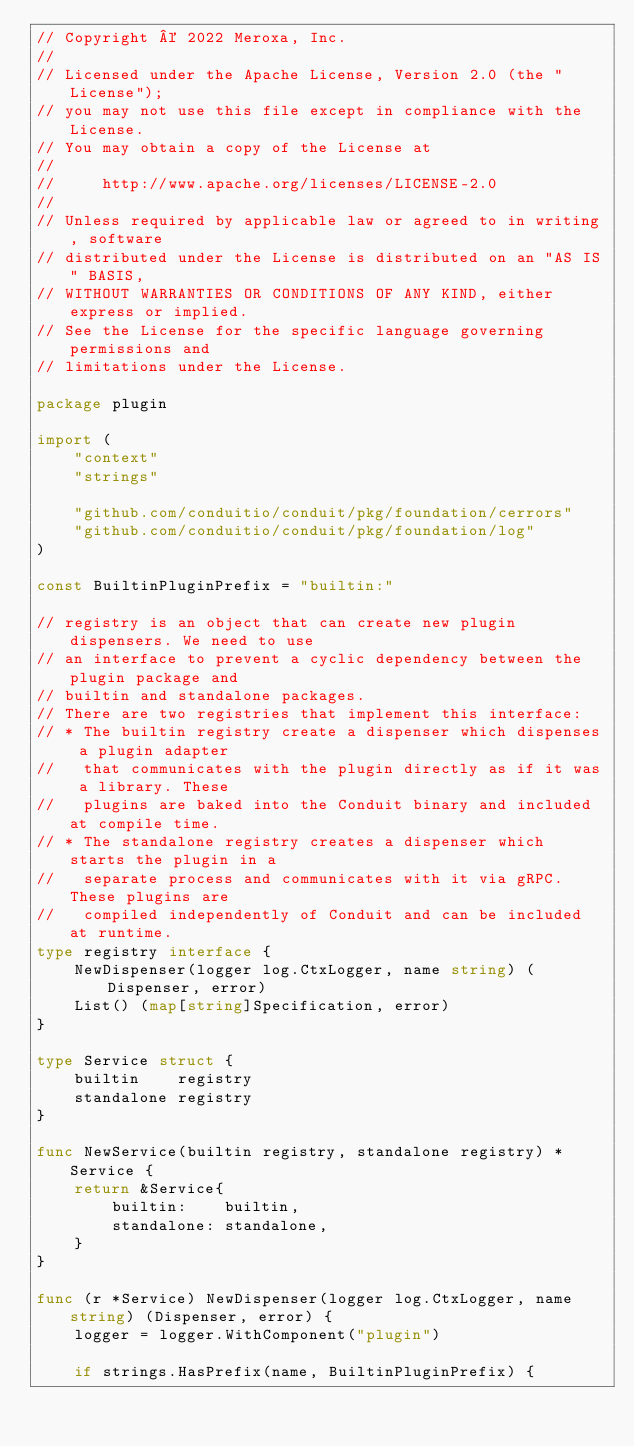<code> <loc_0><loc_0><loc_500><loc_500><_Go_>// Copyright © 2022 Meroxa, Inc.
//
// Licensed under the Apache License, Version 2.0 (the "License");
// you may not use this file except in compliance with the License.
// You may obtain a copy of the License at
//
//     http://www.apache.org/licenses/LICENSE-2.0
//
// Unless required by applicable law or agreed to in writing, software
// distributed under the License is distributed on an "AS IS" BASIS,
// WITHOUT WARRANTIES OR CONDITIONS OF ANY KIND, either express or implied.
// See the License for the specific language governing permissions and
// limitations under the License.

package plugin

import (
	"context"
	"strings"

	"github.com/conduitio/conduit/pkg/foundation/cerrors"
	"github.com/conduitio/conduit/pkg/foundation/log"
)

const BuiltinPluginPrefix = "builtin:"

// registry is an object that can create new plugin dispensers. We need to use
// an interface to prevent a cyclic dependency between the plugin package and
// builtin and standalone packages.
// There are two registries that implement this interface:
// * The builtin registry create a dispenser which dispenses a plugin adapter
//   that communicates with the plugin directly as if it was a library. These
//   plugins are baked into the Conduit binary and included at compile time.
// * The standalone registry creates a dispenser which starts the plugin in a
//   separate process and communicates with it via gRPC. These plugins are
//   compiled independently of Conduit and can be included at runtime.
type registry interface {
	NewDispenser(logger log.CtxLogger, name string) (Dispenser, error)
	List() (map[string]Specification, error)
}

type Service struct {
	builtin    registry
	standalone registry
}

func NewService(builtin registry, standalone registry) *Service {
	return &Service{
		builtin:    builtin,
		standalone: standalone,
	}
}

func (r *Service) NewDispenser(logger log.CtxLogger, name string) (Dispenser, error) {
	logger = logger.WithComponent("plugin")

	if strings.HasPrefix(name, BuiltinPluginPrefix) {</code> 